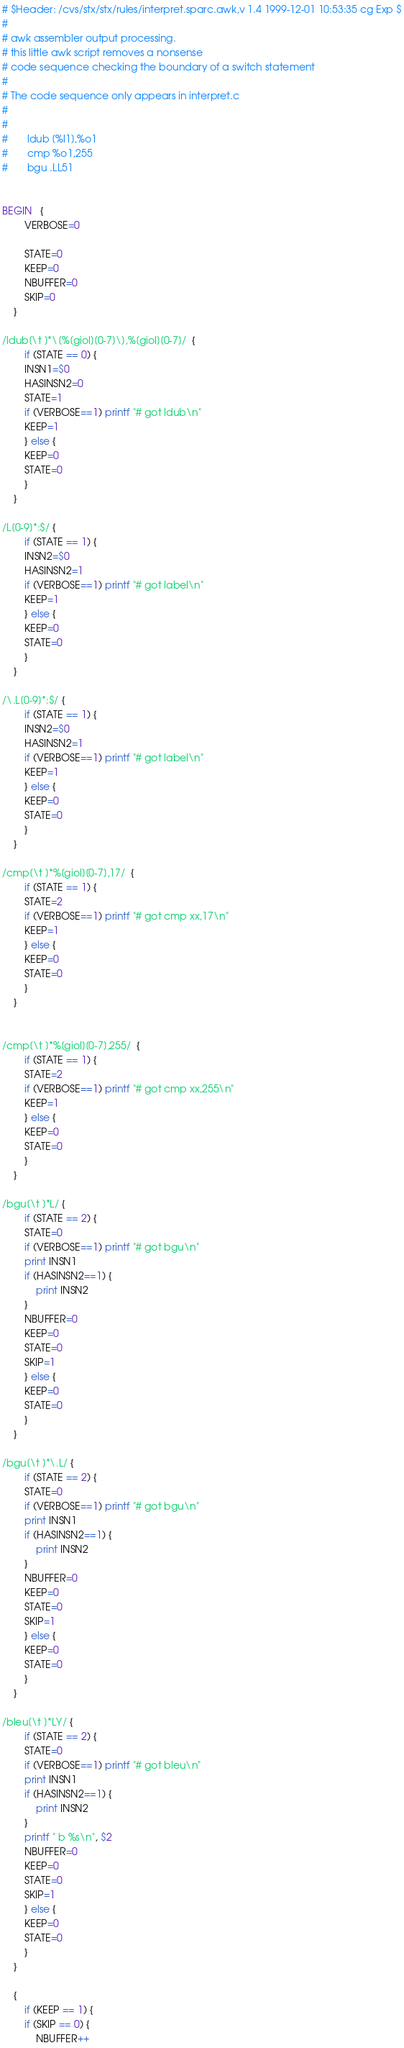<code> <loc_0><loc_0><loc_500><loc_500><_Awk_># $Header: /cvs/stx/stx/rules/interpret.sparc.awk,v 1.4 1999-12-01 10:53:35 cg Exp $
#
# awk assembler output processing.
# this little awk script removes a nonsense
# code sequence checking the boundary of a switch statement
#
# The code sequence only appears in interpret.c
#
#
#       ldub [%l1],%o1
#       cmp %o1,255
#       bgu .LL51


BEGIN   {
	    VERBOSE=0

	    STATE=0
	    KEEP=0
	    NBUFFER=0
	    SKIP=0
	}

/ldub[\t ]*\[%[giol][0-7]\],%[giol][0-7]/  {
	    if (STATE == 0) {
		INSN1=$0
		HASINSN2=0
		STATE=1
		if (VERBOSE==1) printf "# got ldub\n"
		KEEP=1
	    } else {
		KEEP=0
		STATE=0
	    }
	}

/L[0-9]*:$/ {
	    if (STATE == 1) {
		INSN2=$0
		HASINSN2=1
		if (VERBOSE==1) printf "# got label\n"
		KEEP=1
	    } else {
		KEEP=0
		STATE=0
	    }
	}

/\.L[0-9]*:$/ {
	    if (STATE == 1) {
		INSN2=$0
		HASINSN2=1
		if (VERBOSE==1) printf "# got label\n"
		KEEP=1
	    } else {
		KEEP=0
		STATE=0
	    }
	}

/cmp[\t ]*%[giol][0-7],17/  {
	    if (STATE == 1) {
		STATE=2
		if (VERBOSE==1) printf "# got cmp xx,17\n"
		KEEP=1
	    } else {
		KEEP=0
		STATE=0
	    }
	}
 

/cmp[\t ]*%[giol][0-7],255/  {
	    if (STATE == 1) {
		STATE=2
		if (VERBOSE==1) printf "# got cmp xx,255\n"
		KEEP=1
	    } else {
		KEEP=0
		STATE=0
	    }
	}

/bgu[\t ]*L/ {
	    if (STATE == 2) {
		STATE=0
		if (VERBOSE==1) printf "# got bgu\n"
		print INSN1
		if (HASINSN2==1) {
		    print INSN2
		}
		NBUFFER=0
		KEEP=0
		STATE=0
		SKIP=1
	    } else {
		KEEP=0
		STATE=0
	    }
	}

/bgu[\t ]*\.L/ {
	    if (STATE == 2) {
		STATE=0
		if (VERBOSE==1) printf "# got bgu\n"
		print INSN1
		if (HASINSN2==1) {
		    print INSN2
		}
		NBUFFER=0
		KEEP=0
		STATE=0
		SKIP=1
	    } else {
		KEEP=0
		STATE=0
	    }
	}

/bleu[\t ]*LY/ {
	    if (STATE == 2) {
		STATE=0
		if (VERBOSE==1) printf "# got bleu\n"
		print INSN1
		if (HASINSN2==1) {
		    print INSN2
		}
		printf " b %s\n", $2
		NBUFFER=0
		KEEP=0
		STATE=0
		SKIP=1
	    } else {
		KEEP=0
		STATE=0
	    }
	}

	{
	    if (KEEP == 1) {
		if (SKIP == 0) {
		    NBUFFER++</code> 